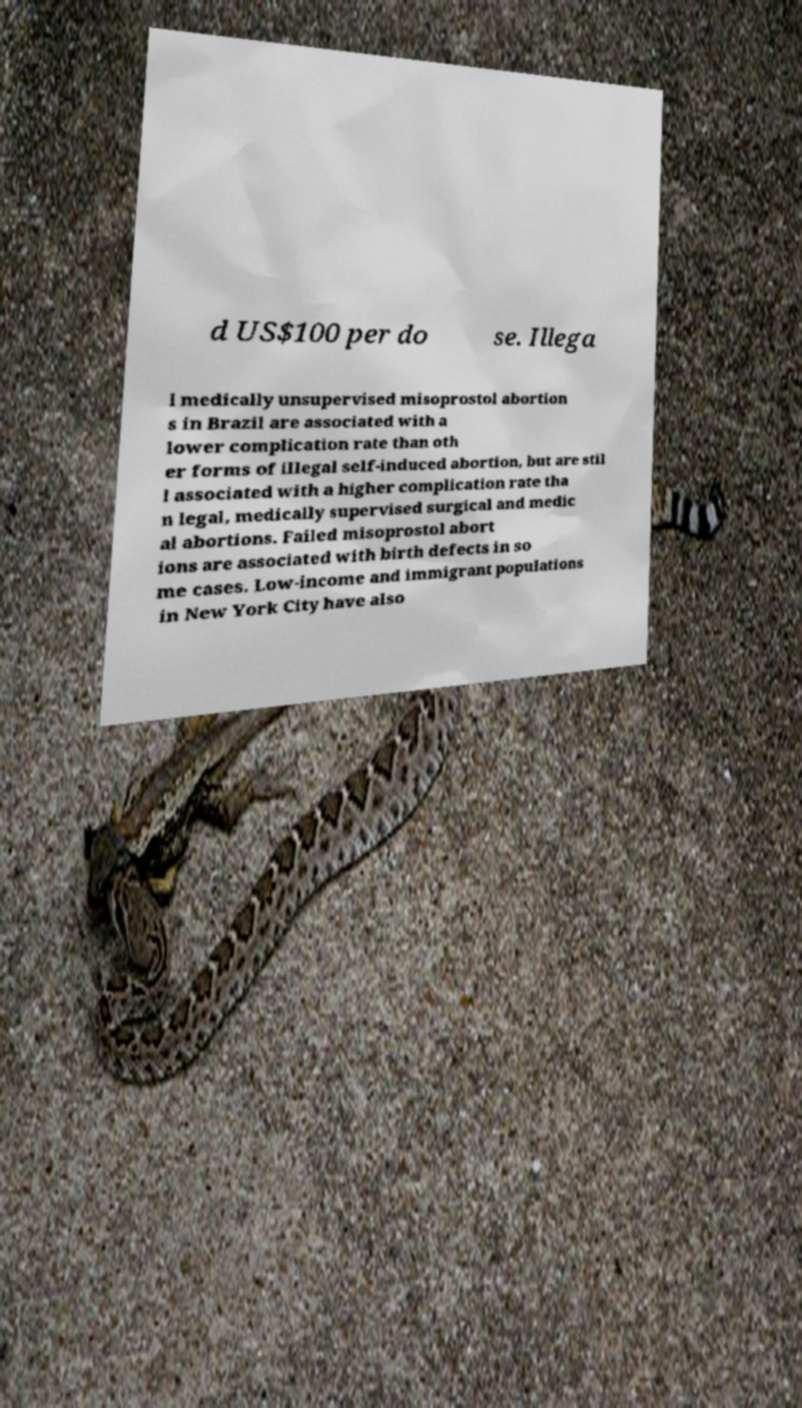Could you assist in decoding the text presented in this image and type it out clearly? d US$100 per do se. Illega l medically unsupervised misoprostol abortion s in Brazil are associated with a lower complication rate than oth er forms of illegal self-induced abortion, but are stil l associated with a higher complication rate tha n legal, medically supervised surgical and medic al abortions. Failed misoprostol abort ions are associated with birth defects in so me cases. Low-income and immigrant populations in New York City have also 